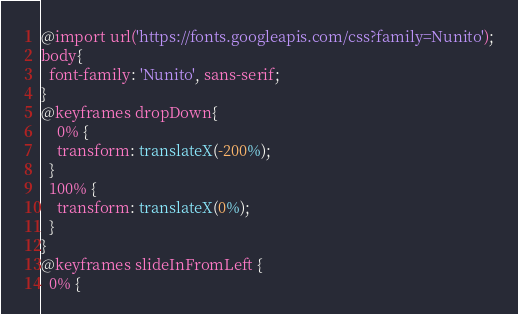<code> <loc_0><loc_0><loc_500><loc_500><_CSS_>@import url('https://fonts.googleapis.com/css?family=Nunito');
body{
  font-family: 'Nunito', sans-serif;
}
@keyframes dropDown{
    0% {
    transform: translateX(-200%);
  }
  100% {
    transform: translateX(0%);
  }
}
@keyframes slideInFromLeft {
  0% {</code> 